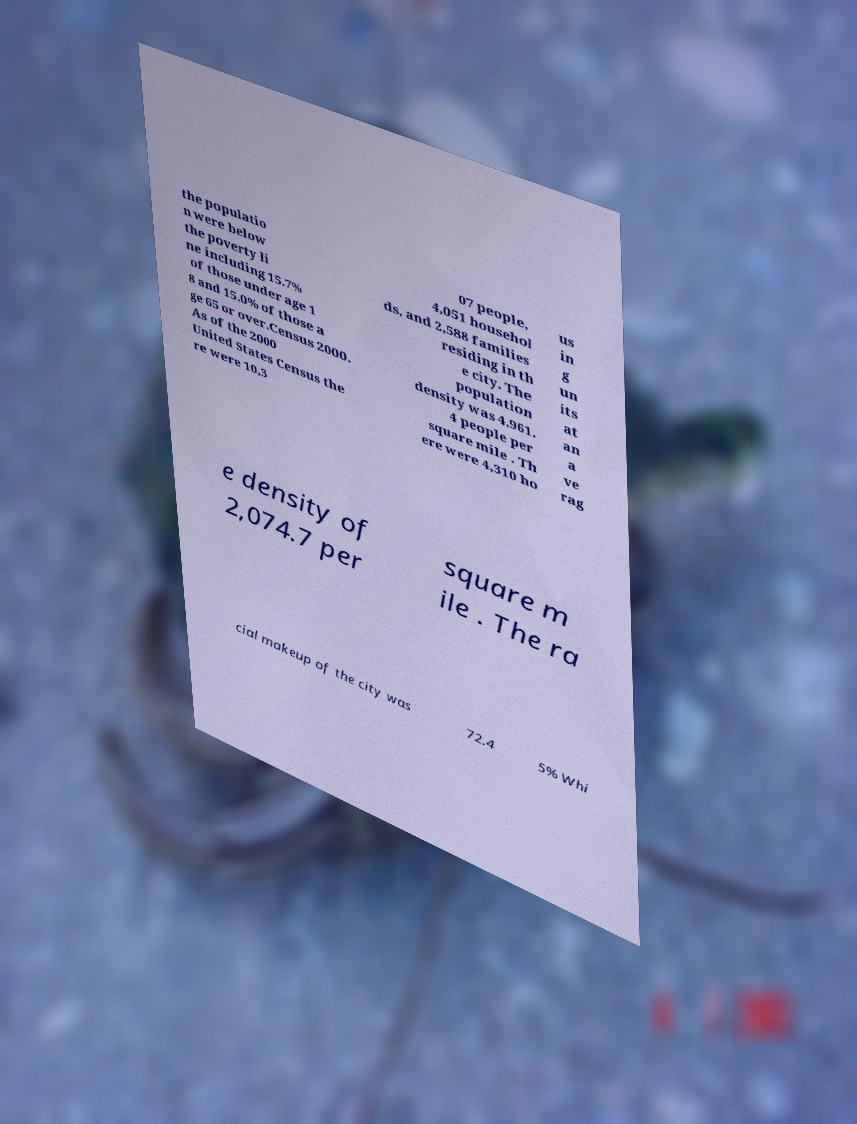I need the written content from this picture converted into text. Can you do that? the populatio n were below the poverty li ne including 15.7% of those under age 1 8 and 15.0% of those a ge 65 or over.Census 2000. As of the 2000 United States Census the re were 10,3 07 people, 4,051 househol ds, and 2,588 families residing in th e city. The population density was 4,961. 4 people per square mile . Th ere were 4,310 ho us in g un its at an a ve rag e density of 2,074.7 per square m ile . The ra cial makeup of the city was 72.4 5% Whi 